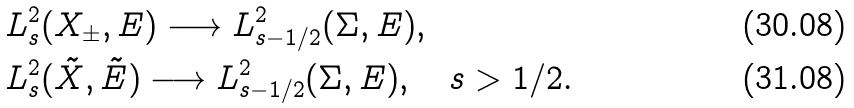<formula> <loc_0><loc_0><loc_500><loc_500>& L ^ { 2 } _ { s } ( X _ { \pm } , E ) \longrightarrow L ^ { 2 } _ { s - 1 / 2 } ( \Sigma , E ) , \\ & L ^ { 2 } _ { s } ( \tilde { X } , \tilde { E } ) \longrightarrow L ^ { 2 } _ { s - 1 / 2 } ( \Sigma , E ) , \quad s > 1 / 2 .</formula> 